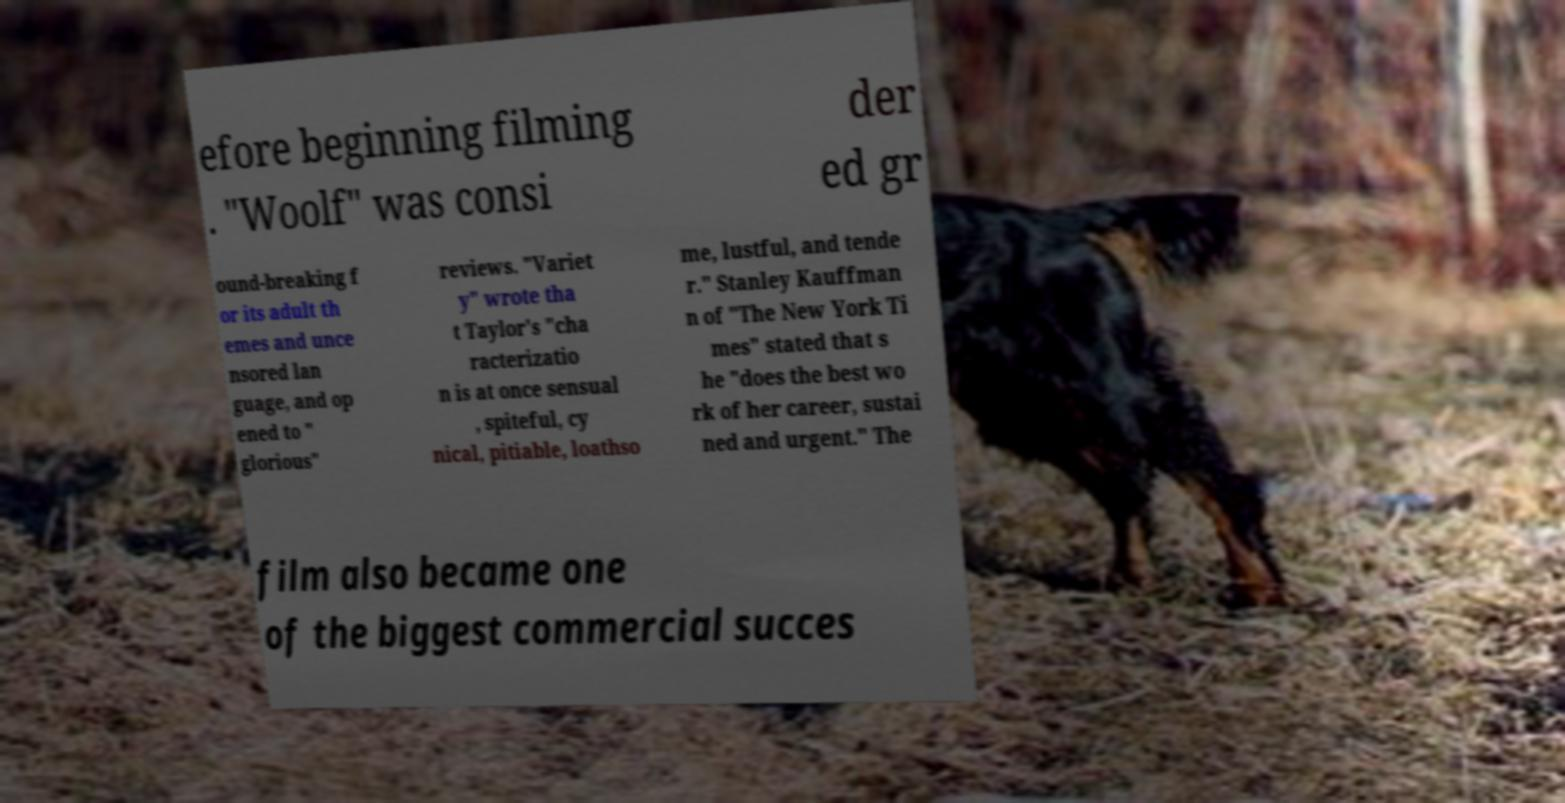Can you accurately transcribe the text from the provided image for me? efore beginning filming . "Woolf" was consi der ed gr ound-breaking f or its adult th emes and unce nsored lan guage, and op ened to " glorious" reviews. "Variet y" wrote tha t Taylor's "cha racterizatio n is at once sensual , spiteful, cy nical, pitiable, loathso me, lustful, and tende r." Stanley Kauffman n of "The New York Ti mes" stated that s he "does the best wo rk of her career, sustai ned and urgent." The film also became one of the biggest commercial succes 